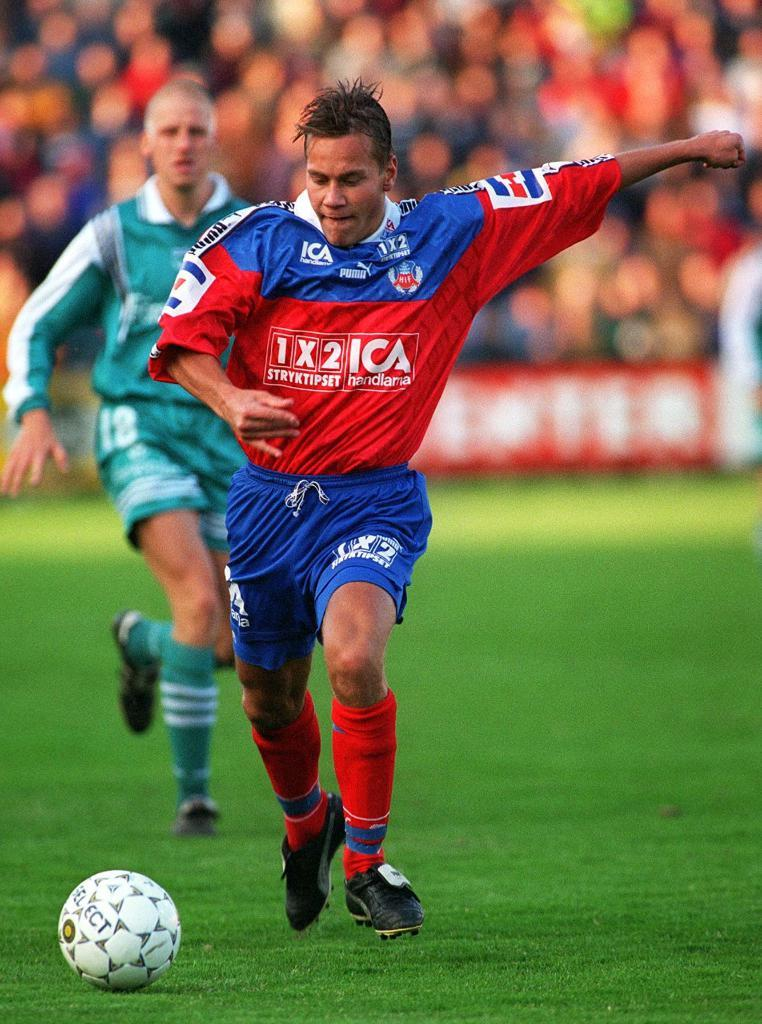<image>
Give a short and clear explanation of the subsequent image. A player whose jersey says 1x2 ICA on it is about to kick the ball. 